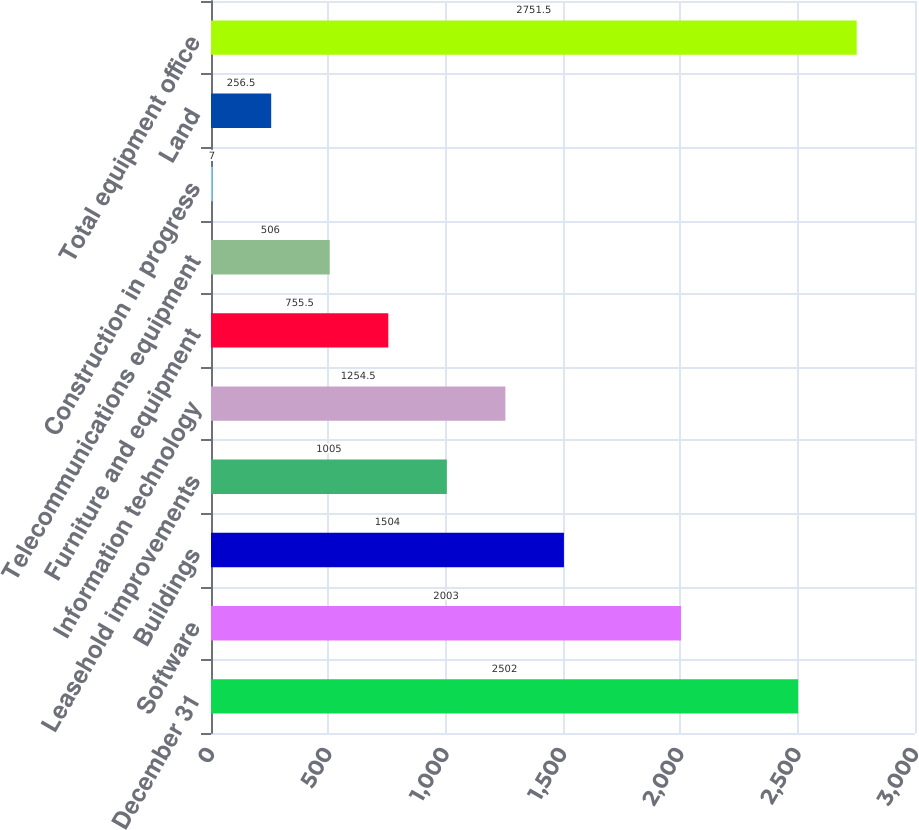Convert chart to OTSL. <chart><loc_0><loc_0><loc_500><loc_500><bar_chart><fcel>December 31<fcel>Software<fcel>Buildings<fcel>Leasehold improvements<fcel>Information technology<fcel>Furniture and equipment<fcel>Telecommunications equipment<fcel>Construction in progress<fcel>Land<fcel>Total equipment office<nl><fcel>2502<fcel>2003<fcel>1504<fcel>1005<fcel>1254.5<fcel>755.5<fcel>506<fcel>7<fcel>256.5<fcel>2751.5<nl></chart> 